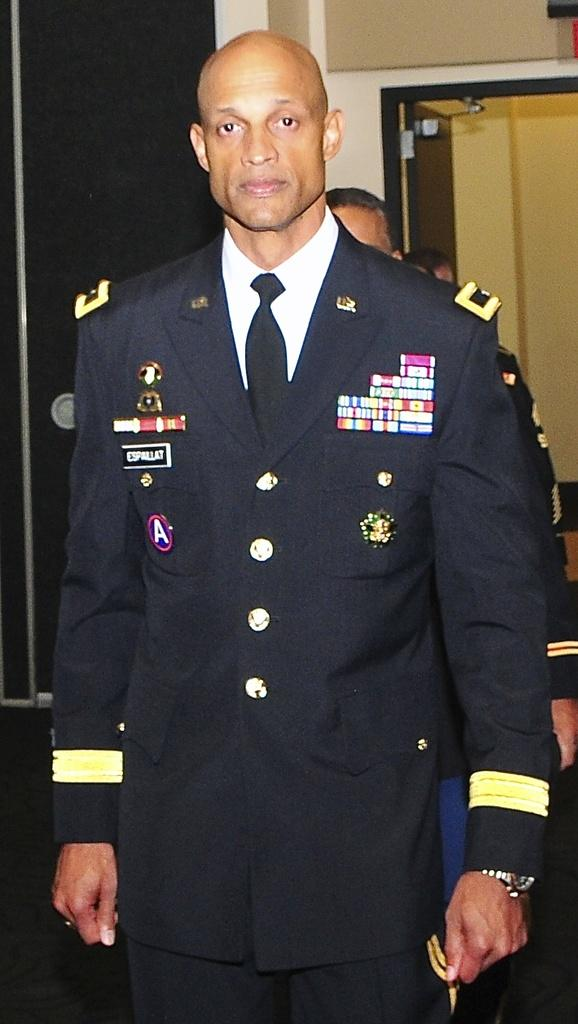How many people are visible in the image? There are a few people in the image. What can be seen on the wall in the image? There is a wall with objects in the image. Can you describe the color of one of the objects in the image? There is a black-colored object in the image. Can you tell me how many bees are buzzing around the black-colored object in the image? There are no bees present in the image; it only features a few people and objects on a wall. 